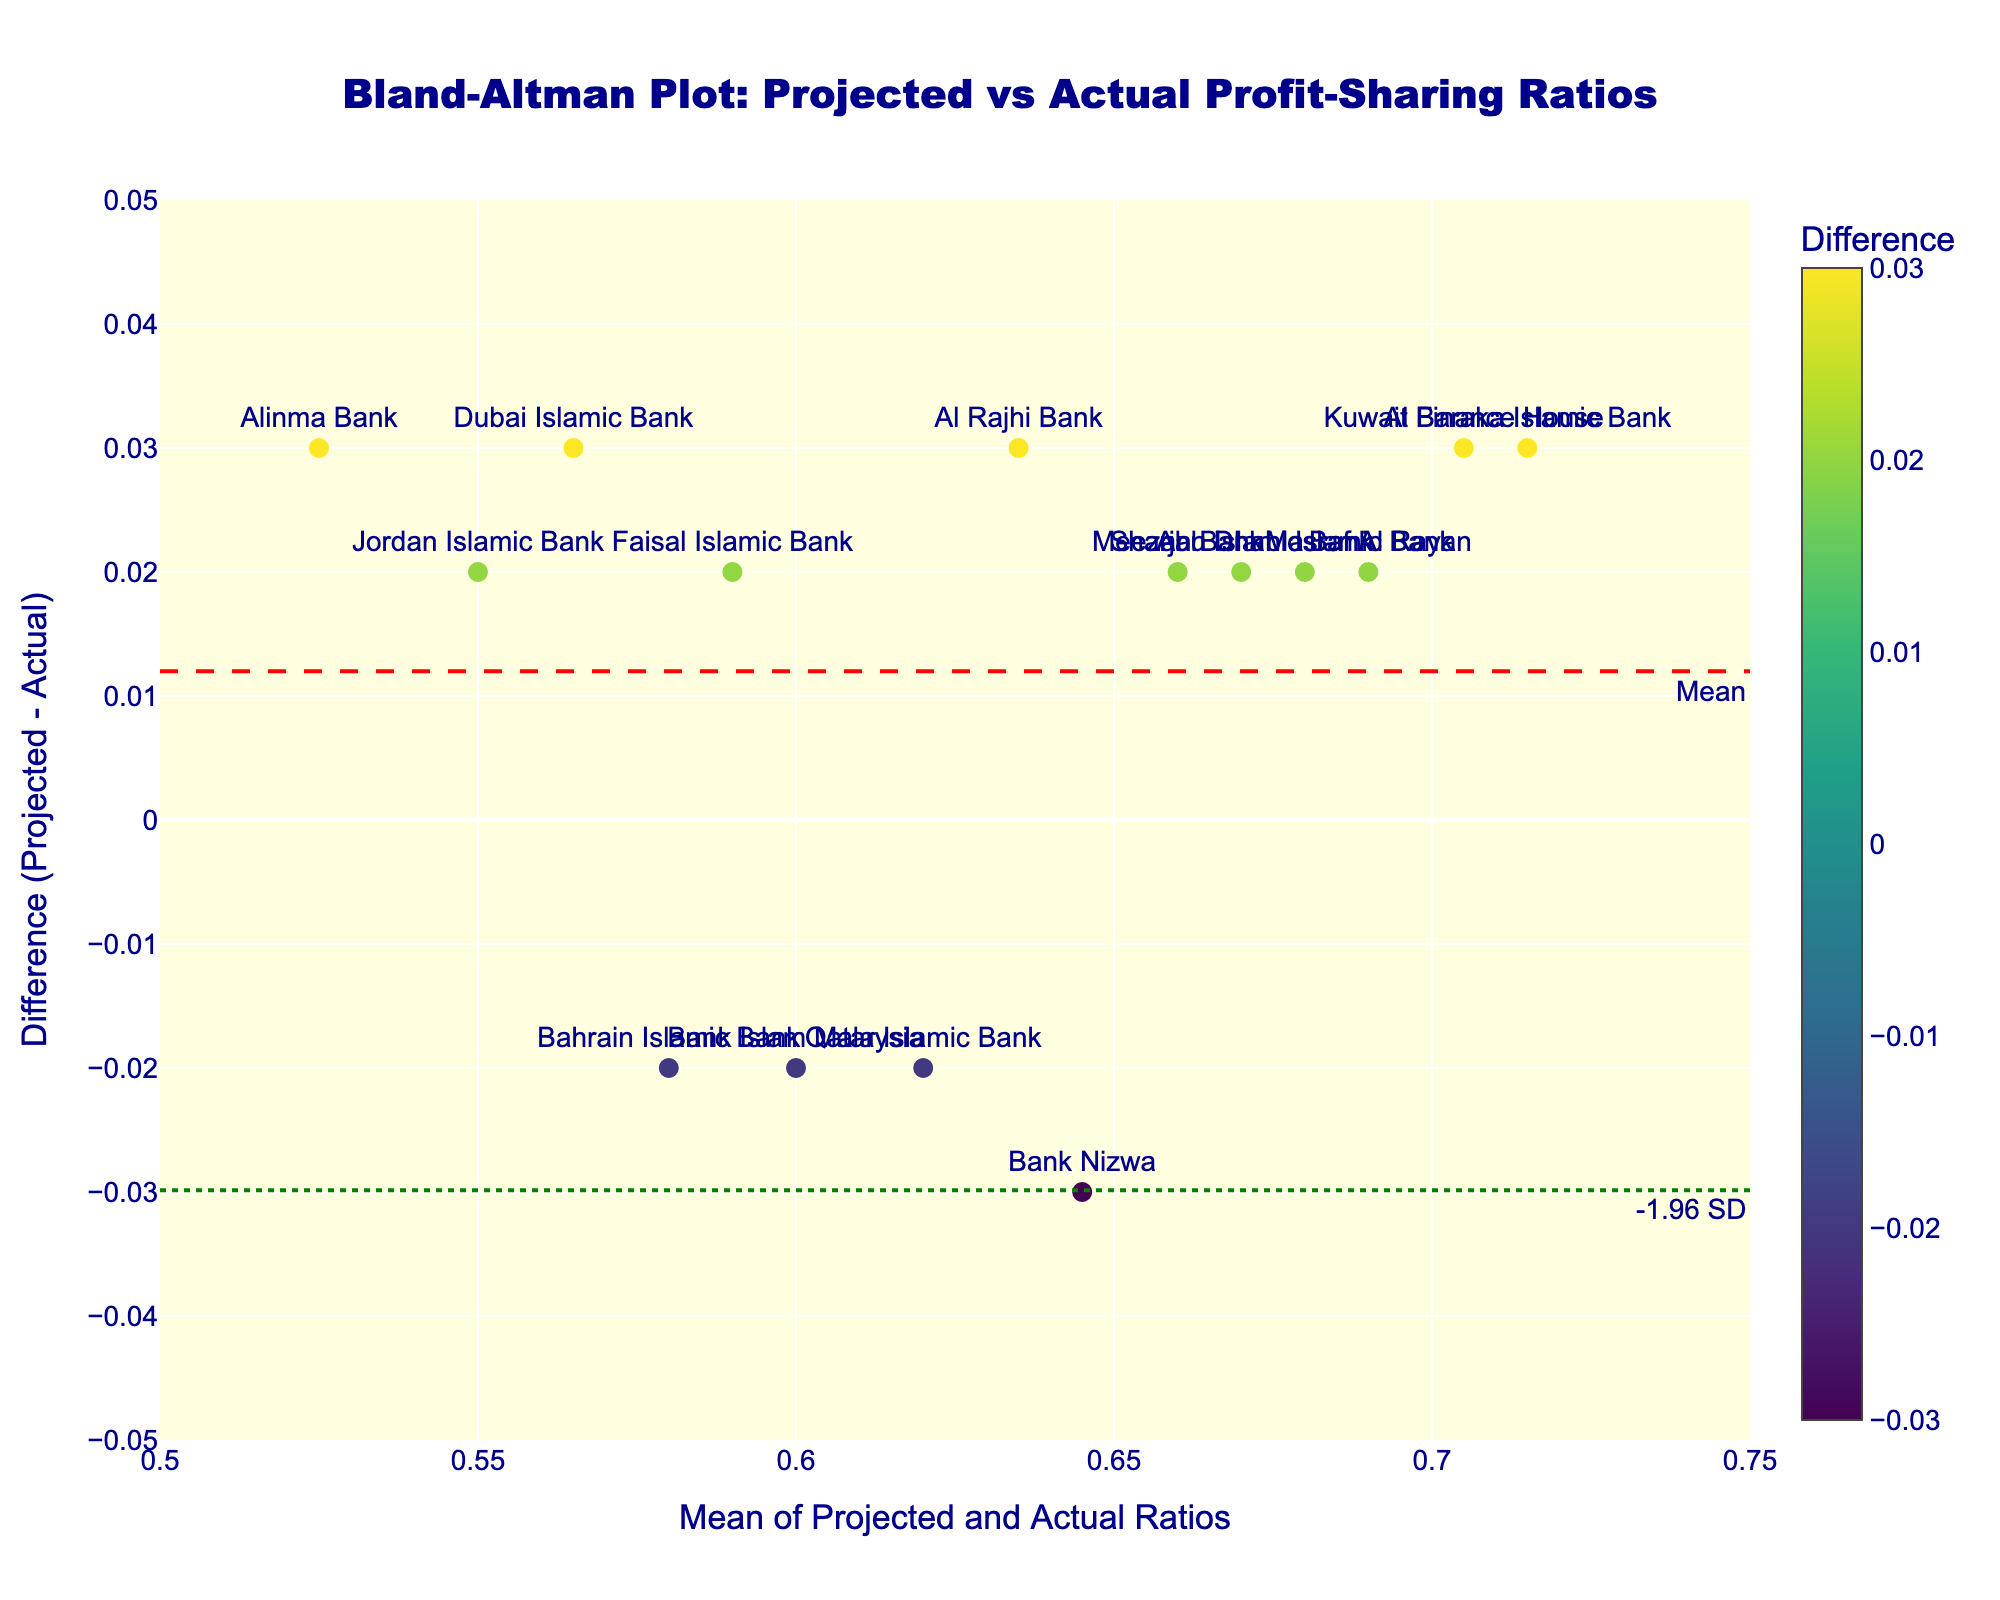What is the title of the plot? The plot's title is displayed prominently at the top.
Answer: Bland-Altman Plot: Projected vs Actual Profit-Sharing Ratios How many data points are there in the plot? The number of unique markers (data points) in the plot can be counted.
Answer: 15 What is the range of the x-axis? The range of the x-axis can be observed from the axis labels.
Answer: 0.5 to 0.75 Which bank has the highest difference between the projected and actual ratios? By hovering over the data points, we can see the differences and identify the bank with the highest value.
Answer: Bank Islam Malaysia What is the mean difference between the projected and actual profit-sharing ratios? The mean difference is represented by the red dashed horizontal line, with an annotation indicating "Mean."
Answer: Close to 0.01 Which two banks have mean values closest to 0.65? By inspecting the plot and identifying data points around x=0.65, we can see the corresponding banks.
Answer: Al Rajhi Bank and Bahrain Islamic Bank What do the green dotted lines represent? The green dotted lines are annotations in the plot and are labelled accordingly.
Answer: Upper and lower limits at ±1.96 SD How many banks have differences within the ±1.96 SD limits? We can count the number of data points falling between the two green dotted lines to get this number.
Answer: 15 What are the axes' labels on the plot? The x-axis and y-axis labels are shown on the plot itself.
Answer: Mean of Projected and Actual Ratios (x-axis) and Difference (Projected - Actual) (y-axis) Are there any points where the actual ratio is greater than the projected ratio? A positive difference indicates the actual ratio is less than the projected. Negative differences indicate the opposite.
Answer: Yes Which bank shows the largest negative difference? The data point with the smallest y-value on the plot shows the largest negative difference. This can be identified by noting the corresponding label.
Answer: Bank Nizwa 